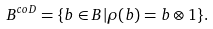Convert formula to latex. <formula><loc_0><loc_0><loc_500><loc_500>B ^ { c o D } = \{ b \in B | \rho ( b ) = b \otimes 1 \} .</formula> 